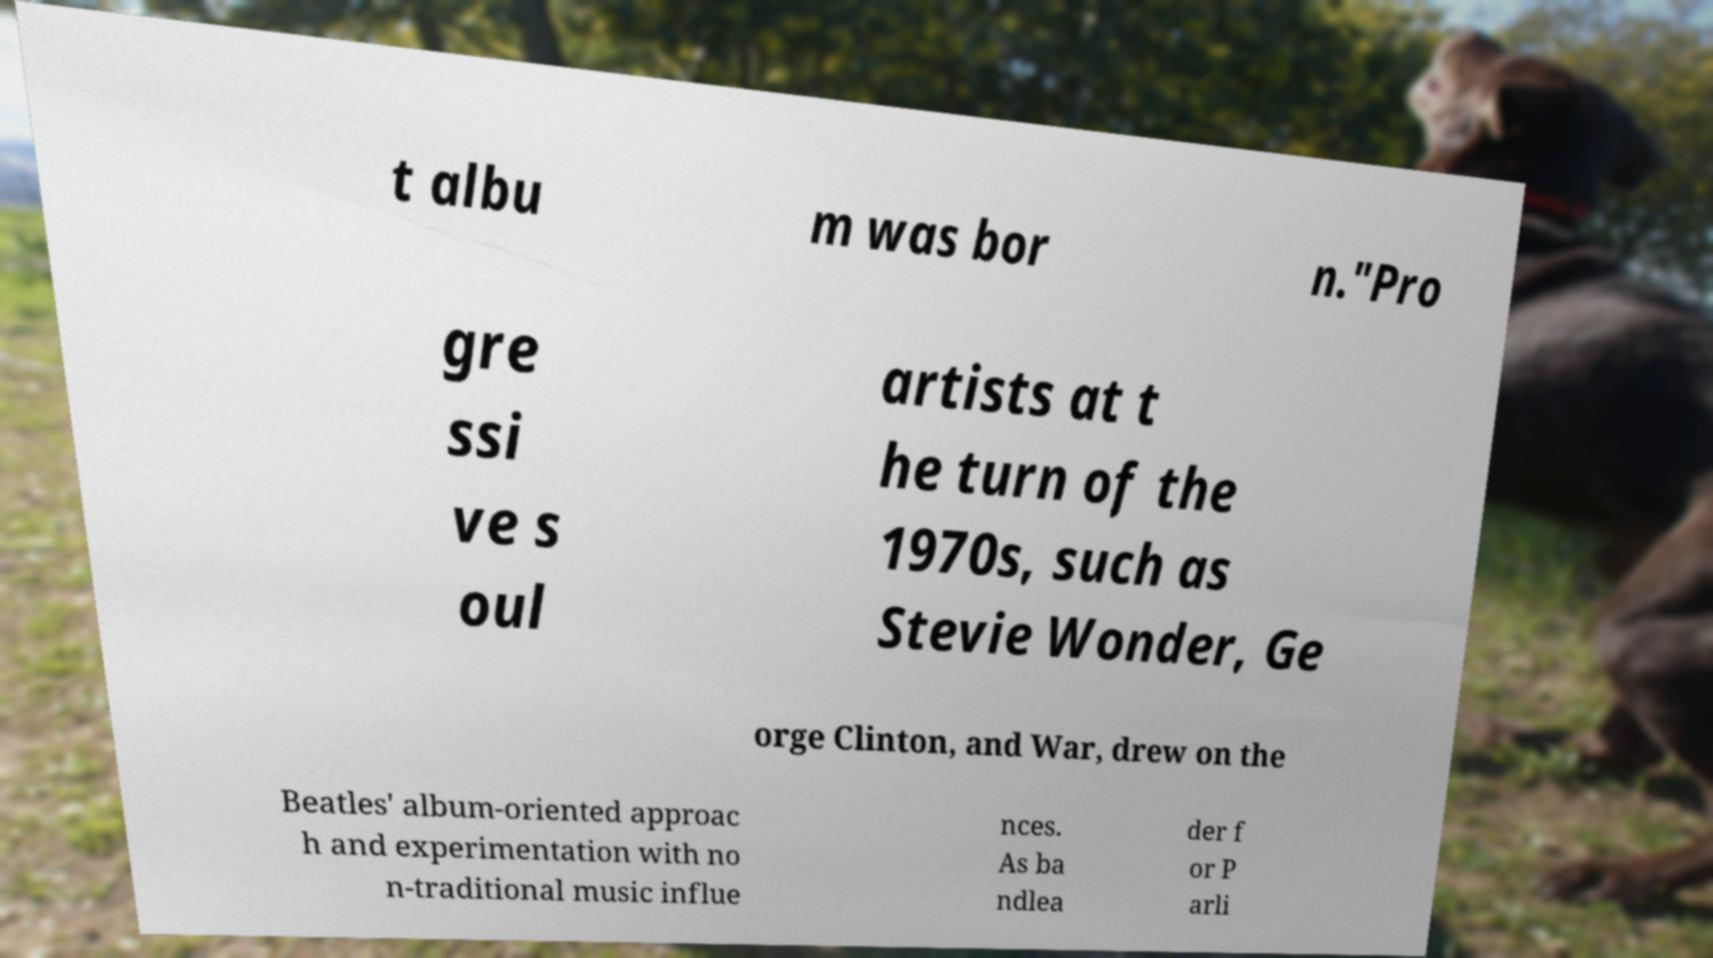There's text embedded in this image that I need extracted. Can you transcribe it verbatim? t albu m was bor n."Pro gre ssi ve s oul artists at t he turn of the 1970s, such as Stevie Wonder, Ge orge Clinton, and War, drew on the Beatles' album-oriented approac h and experimentation with no n-traditional music influe nces. As ba ndlea der f or P arli 